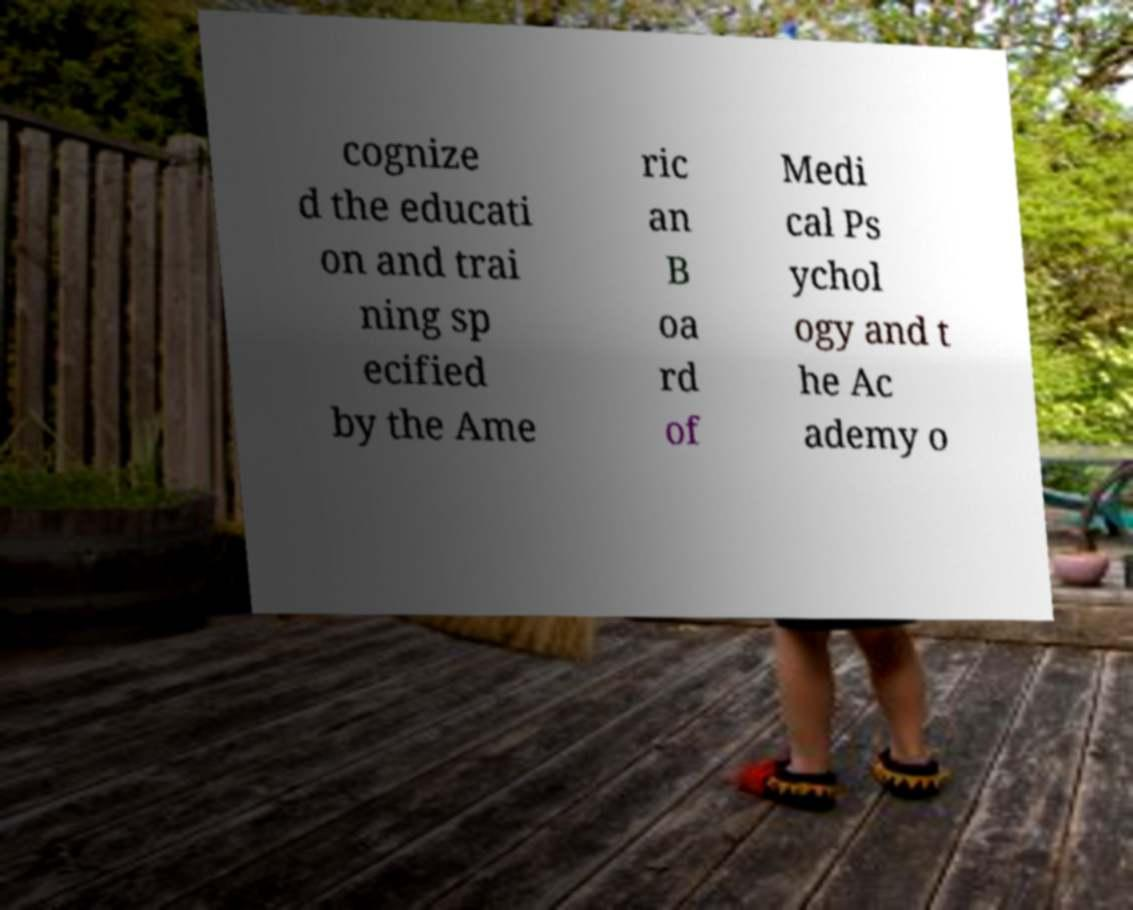Please identify and transcribe the text found in this image. cognize d the educati on and trai ning sp ecified by the Ame ric an B oa rd of Medi cal Ps ychol ogy and t he Ac ademy o 